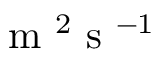<formula> <loc_0><loc_0><loc_500><loc_500>m ^ { 2 } s ^ { - 1 }</formula> 